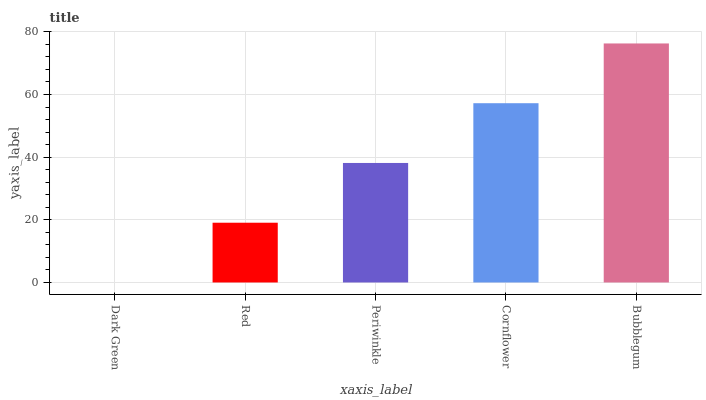Is Dark Green the minimum?
Answer yes or no. Yes. Is Bubblegum the maximum?
Answer yes or no. Yes. Is Red the minimum?
Answer yes or no. No. Is Red the maximum?
Answer yes or no. No. Is Red greater than Dark Green?
Answer yes or no. Yes. Is Dark Green less than Red?
Answer yes or no. Yes. Is Dark Green greater than Red?
Answer yes or no. No. Is Red less than Dark Green?
Answer yes or no. No. Is Periwinkle the high median?
Answer yes or no. Yes. Is Periwinkle the low median?
Answer yes or no. Yes. Is Bubblegum the high median?
Answer yes or no. No. Is Cornflower the low median?
Answer yes or no. No. 